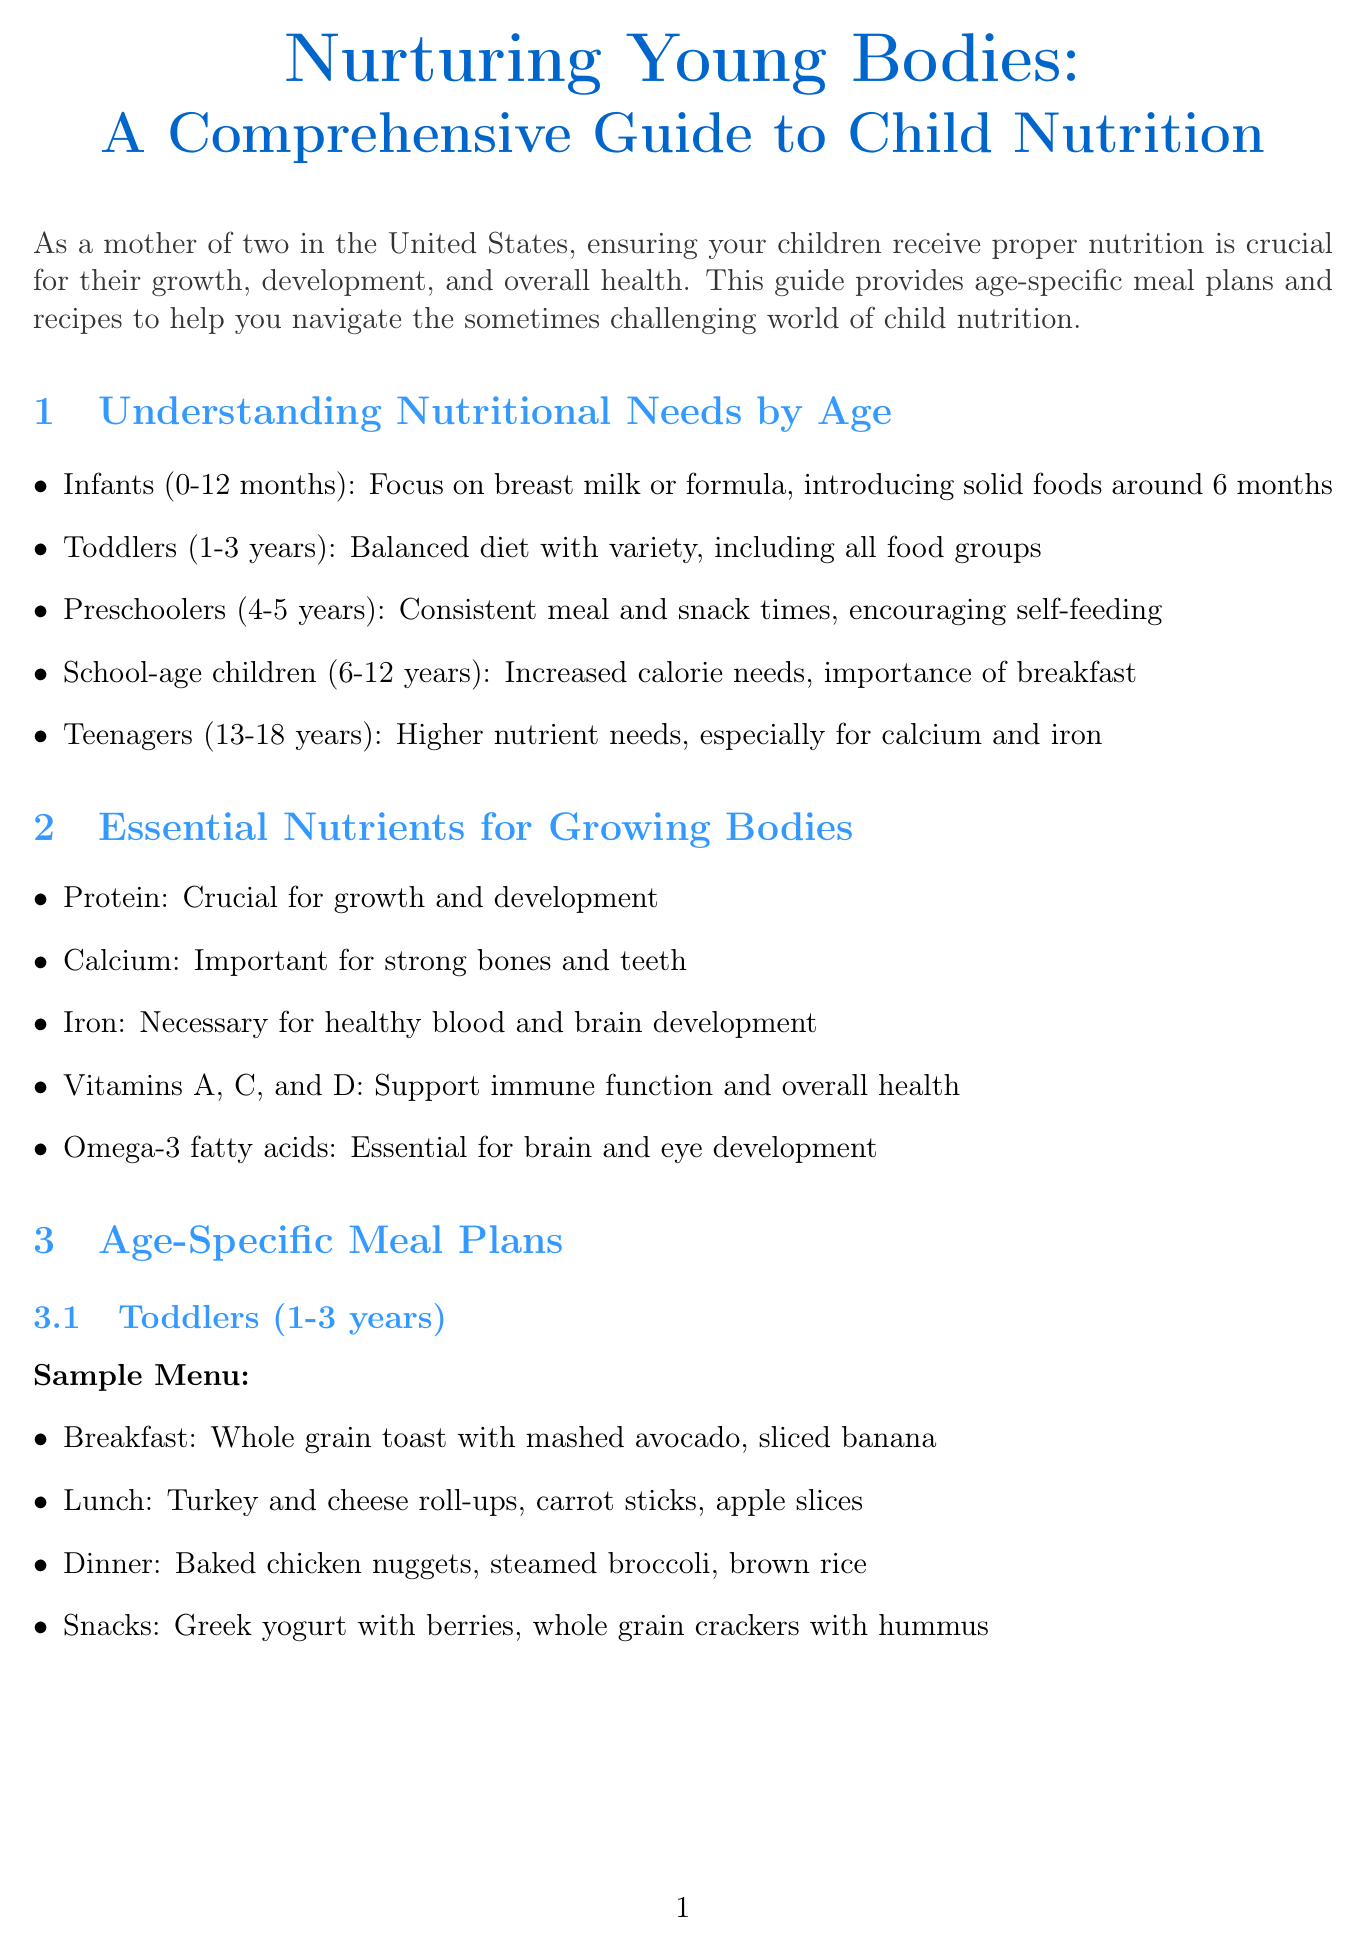What is the title of the newsletter? The title is prominently displayed at the beginning of the document.
Answer: Nurturing Young Bodies: A Comprehensive Guide to Child Nutrition What age group is focused on in the sample menu for toddlers? The document specifies the age group for the meal plans.
Answer: Toddlers (1-3 years) What nutrient is necessary for healthy blood and brain development? The document lists essential nutrients and their functions.
Answer: Iron How many recipes are included in the Kid-Friendly Recipes section? The document specifies the number of recipes provided.
Answer: Two What is a tip for picky eaters? The document provides advice for dealing with picky eaters.
Answer: Involve children in meal planning and preparation Which program should families consider if eligible for nutritional support? The document mentions a specific program for families.
Answer: WIC (Women, Infants, and Children) What is one nutritional concern addressed in the document? The document outlines common nutritional concerns for children.
Answer: Food allergies What is the suggested breakfast for school-age children? The sample menu for school-age children includes specific meals.
Answer: Oatmeal with mixed berries and almonds, milk 